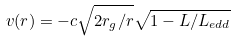<formula> <loc_0><loc_0><loc_500><loc_500>v ( r ) = - c \sqrt { 2 r _ { g } / r } \sqrt { 1 - L / L _ { e d d } }</formula> 